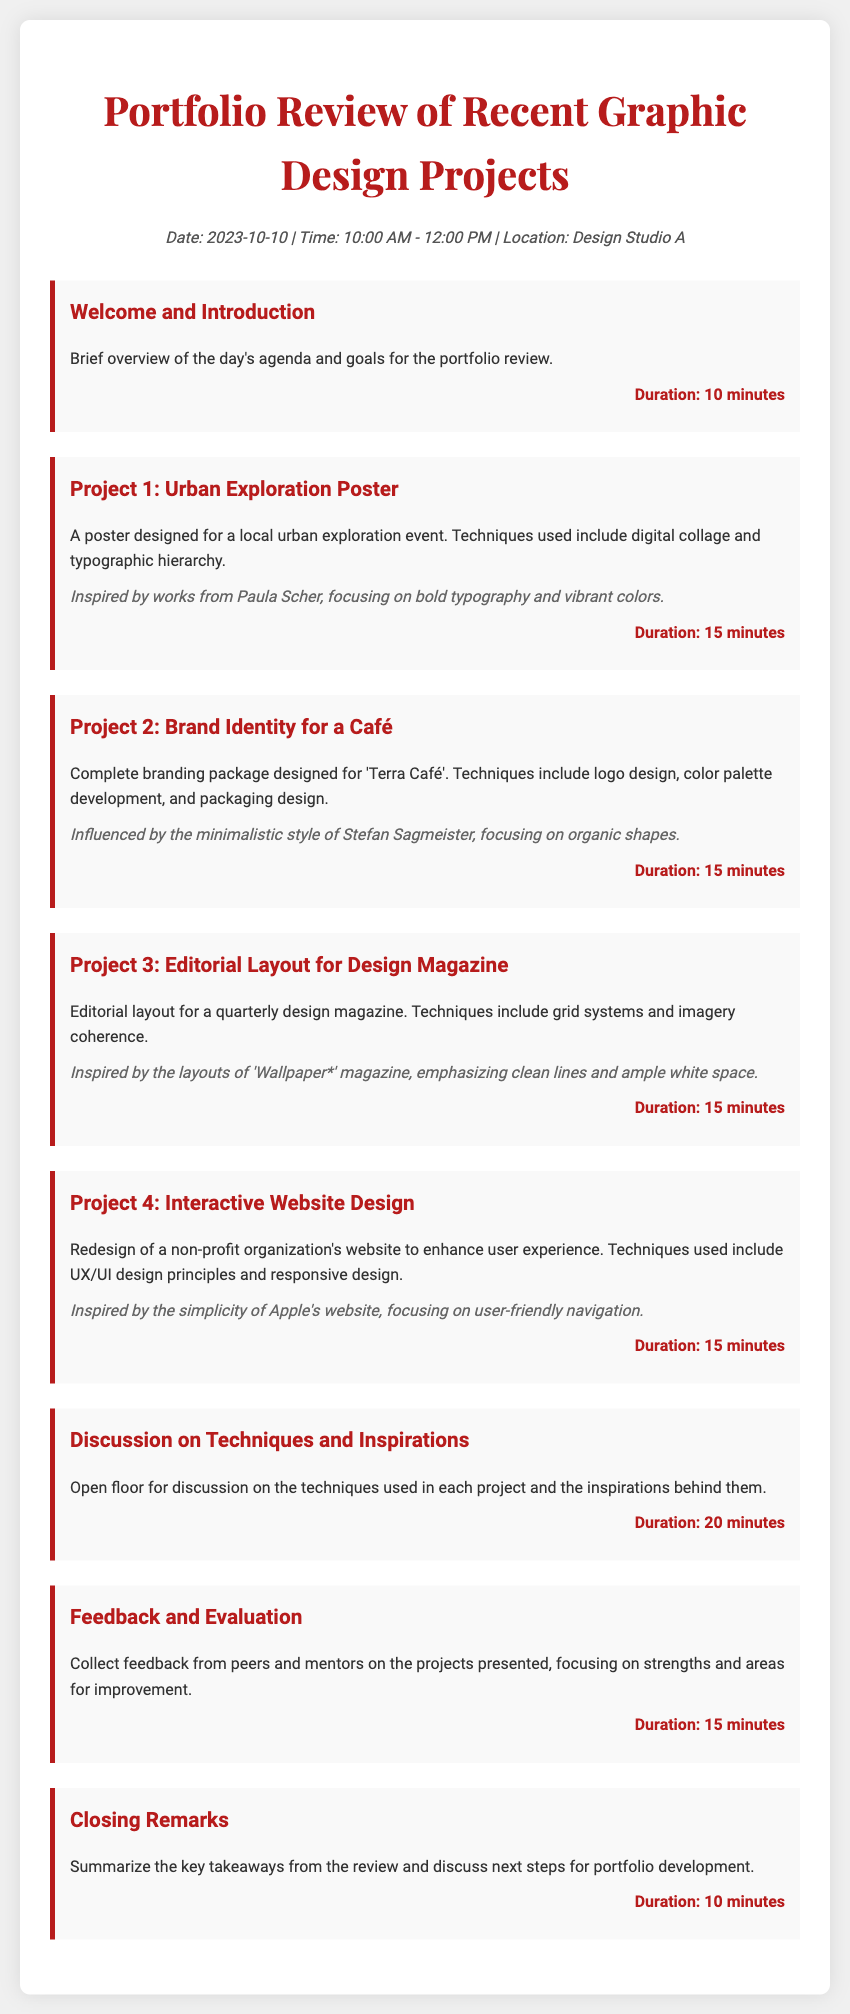What is the date of the portfolio review? The date can be found in the header information of the document, which states "Date: 2023-10-10."
Answer: 2023-10-10 What is the location of the portfolio review? The location is also mentioned in the header information, stating "Location: Design Studio A."
Answer: Design Studio A How long is the welcome and introduction session? This information is provided under the agenda item for "Welcome and Introduction," which specifies the duration.
Answer: 10 minutes What is the focus of Project 2? The document describes Project 2, specifying the branding package designed for a café, indicating its purpose.
Answer: Brand Identity for a Café Who is the inspiration for Project 3? The inspiration for Project 3 is listed in the project description, where it mentions an influential magazine.
Answer: 'Wallpaper*' magazine How long is the discussion on techniques and inspirations? The duration for this discussion is provided in the agenda, detailing how long it will take.
Answer: 20 minutes What is one technique used in Project 4? The document lists techniques used in Project 4 under the respective project description.
Answer: UX/UI design principles What will happen during the feedback and evaluation section? The goals of the feedback and evaluation section are provided, highlighting what participants will do.
Answer: Collect feedback What is discussed in the closing remarks? The closing remarks summarize key takeaways and next steps for further development, describing the main focus of this section.
Answer: Key takeaways and next steps 